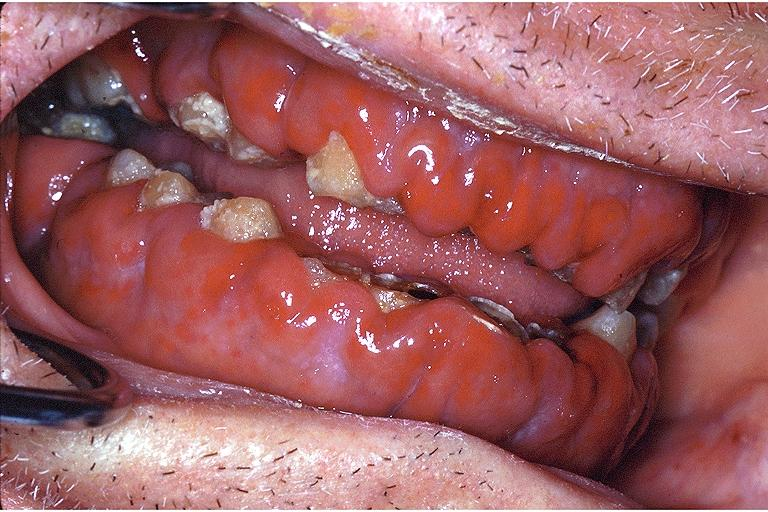s leiomyoma present?
Answer the question using a single word or phrase. No 